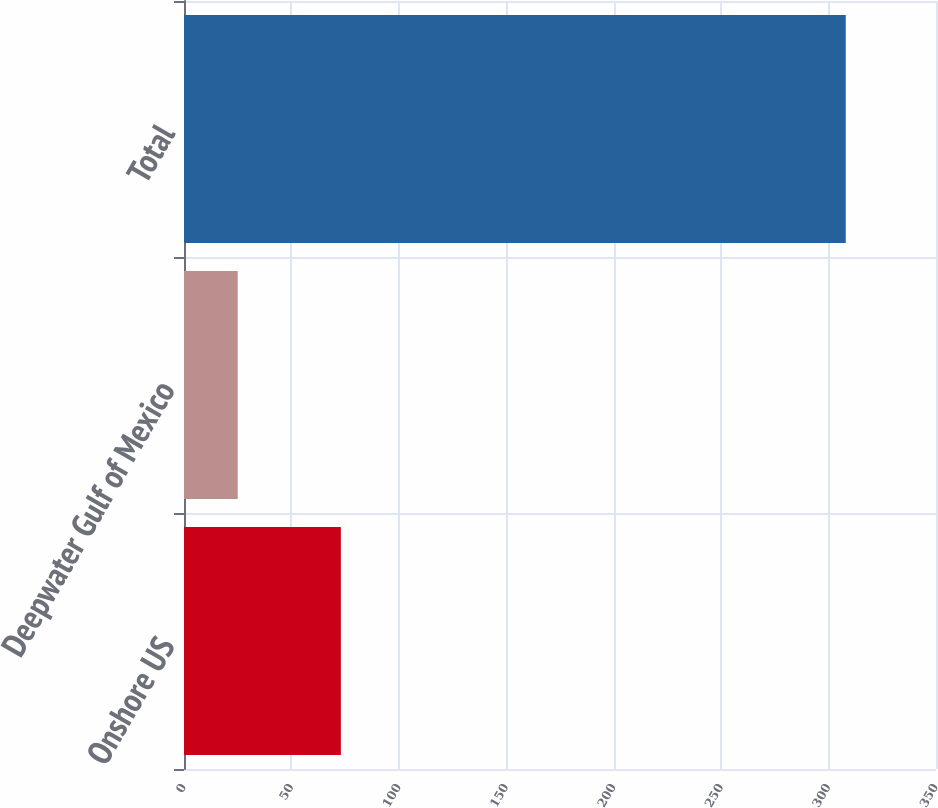Convert chart. <chart><loc_0><loc_0><loc_500><loc_500><bar_chart><fcel>Onshore US<fcel>Deepwater Gulf of Mexico<fcel>Total<nl><fcel>73<fcel>25<fcel>308<nl></chart> 